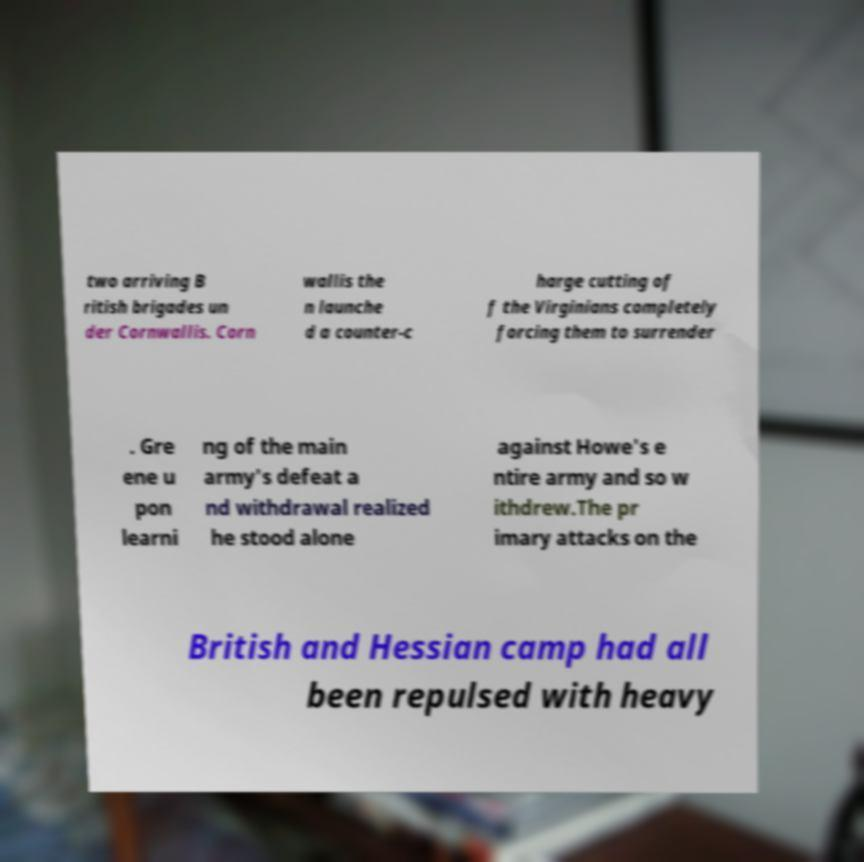Can you accurately transcribe the text from the provided image for me? two arriving B ritish brigades un der Cornwallis. Corn wallis the n launche d a counter-c harge cutting of f the Virginians completely forcing them to surrender . Gre ene u pon learni ng of the main army's defeat a nd withdrawal realized he stood alone against Howe's e ntire army and so w ithdrew.The pr imary attacks on the British and Hessian camp had all been repulsed with heavy 